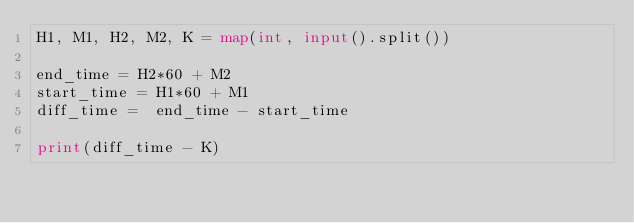<code> <loc_0><loc_0><loc_500><loc_500><_Python_>H1, M1, H2, M2, K = map(int, input().split())

end_time = H2*60 + M2
start_time = H1*60 + M1
diff_time =  end_time - start_time

print(diff_time - K)</code> 